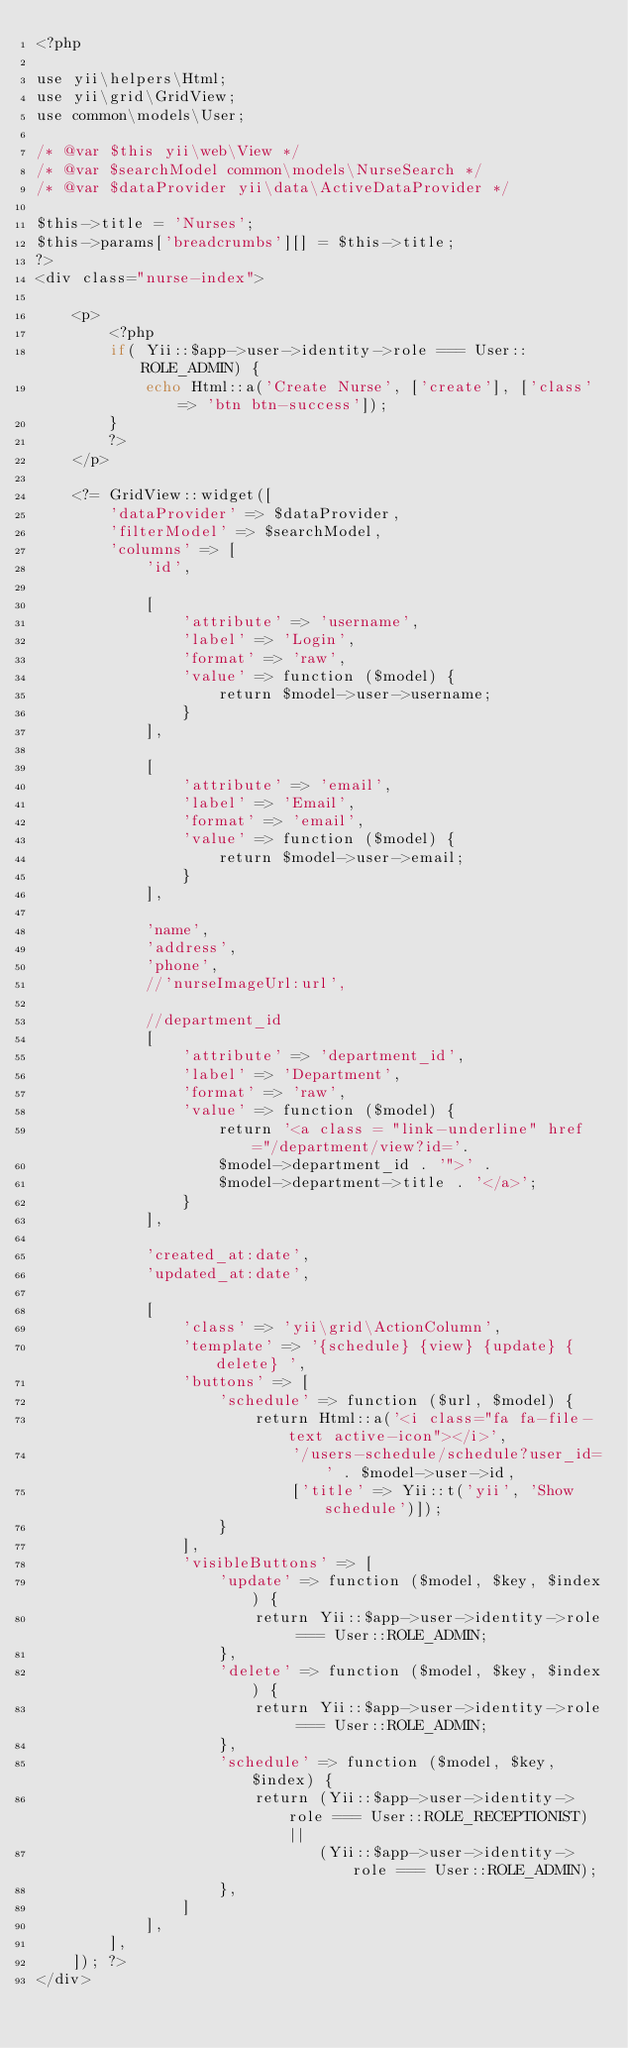<code> <loc_0><loc_0><loc_500><loc_500><_PHP_><?php

use yii\helpers\Html;
use yii\grid\GridView;
use common\models\User;

/* @var $this yii\web\View */
/* @var $searchModel common\models\NurseSearch */
/* @var $dataProvider yii\data\ActiveDataProvider */

$this->title = 'Nurses';
$this->params['breadcrumbs'][] = $this->title;
?>
<div class="nurse-index">

    <p>
        <?php
        if( Yii::$app->user->identity->role === User::ROLE_ADMIN) {
            echo Html::a('Create Nurse', ['create'], ['class' => 'btn btn-success']);
        }
        ?>
    </p>

    <?= GridView::widget([
        'dataProvider' => $dataProvider,
        'filterModel' => $searchModel,
        'columns' => [
            'id',

            [
                'attribute' => 'username',
                'label' => 'Login',
                'format' => 'raw',
                'value' => function ($model) {
                    return $model->user->username;
                }
            ],

            [
                'attribute' => 'email',
                'label' => 'Email',
                'format' => 'email',
                'value' => function ($model) {
                    return $model->user->email;
                }
            ],

            'name',
            'address',
            'phone',
            //'nurseImageUrl:url',

            //department_id
            [
                'attribute' => 'department_id',
                'label' => 'Department',
                'format' => 'raw',
                'value' => function ($model) {
                    return '<a class = "link-underline" href="/department/view?id='.
                    $model->department_id . '">' .
                    $model->department->title . '</a>';
                }
            ],

            'created_at:date',
            'updated_at:date',

            [
                'class' => 'yii\grid\ActionColumn',
                'template' => '{schedule} {view} {update} {delete} ',
                'buttons' => [
                    'schedule' => function ($url, $model) {
                        return Html::a('<i class="fa fa-file-text active-icon"></i>',
                            '/users-schedule/schedule?user_id=' . $model->user->id,
                            ['title' => Yii::t('yii', 'Show schedule')]);
                    }
                ],
                'visibleButtons' => [
                    'update' => function ($model, $key, $index) {
                        return Yii::$app->user->identity->role === User::ROLE_ADMIN;
                    },
                    'delete' => function ($model, $key, $index) {
                        return Yii::$app->user->identity->role === User::ROLE_ADMIN;
                    },
                    'schedule' => function ($model, $key, $index) {
                        return (Yii::$app->user->identity->role === User::ROLE_RECEPTIONIST) ||
                               (Yii::$app->user->identity->role === User::ROLE_ADMIN);
                    },
                ]
            ],
        ],
    ]); ?>
</div>
</code> 